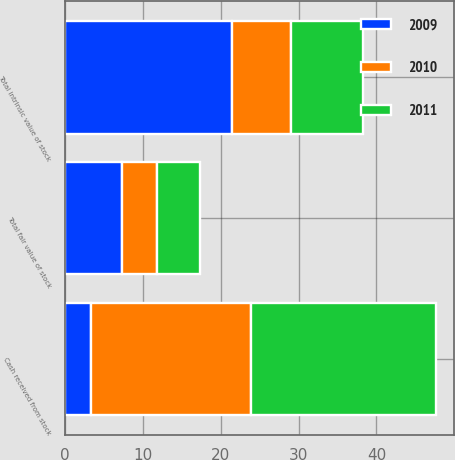Convert chart. <chart><loc_0><loc_0><loc_500><loc_500><stacked_bar_chart><ecel><fcel>Total intrinsic value of stock<fcel>Cash received from stock<fcel>Total fair value of stock<nl><fcel>2010<fcel>7.5<fcel>20.5<fcel>4.5<nl><fcel>2011<fcel>9.3<fcel>23.7<fcel>5.5<nl><fcel>2009<fcel>21.5<fcel>3.4<fcel>7.3<nl></chart> 